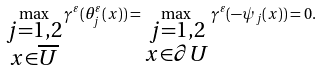<formula> <loc_0><loc_0><loc_500><loc_500>\max _ { \substack { j = 1 , 2 \\ x \in \overline { U } } } \gamma ^ { \varepsilon } ( \theta ^ { \varepsilon } _ { j } ( x ) ) = \max _ { \substack { j = 1 , 2 \\ x \in \partial U } } \gamma ^ { \varepsilon } ( - \psi _ { j } ( x ) ) = 0 .</formula> 